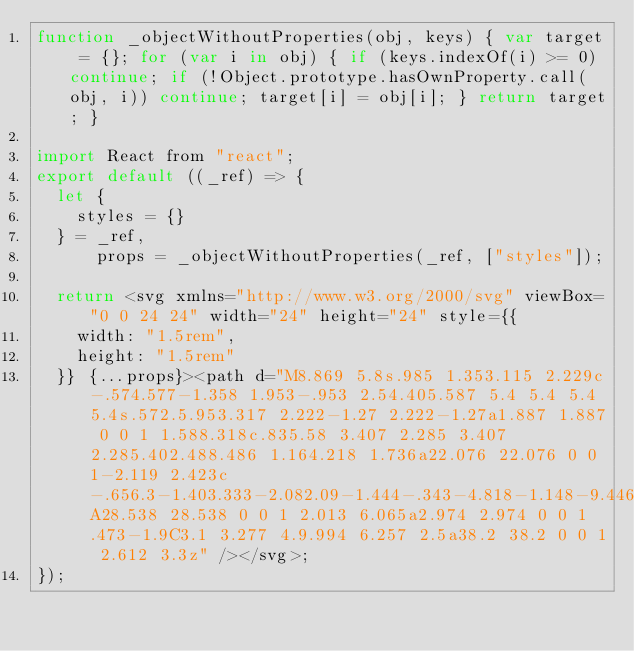<code> <loc_0><loc_0><loc_500><loc_500><_JavaScript_>function _objectWithoutProperties(obj, keys) { var target = {}; for (var i in obj) { if (keys.indexOf(i) >= 0) continue; if (!Object.prototype.hasOwnProperty.call(obj, i)) continue; target[i] = obj[i]; } return target; }

import React from "react";
export default ((_ref) => {
  let {
    styles = {}
  } = _ref,
      props = _objectWithoutProperties(_ref, ["styles"]);

  return <svg xmlns="http://www.w3.org/2000/svg" viewBox="0 0 24 24" width="24" height="24" style={{
    width: "1.5rem",
    height: "1.5rem"
  }} {...props}><path d="M8.869 5.8s.985 1.353.115 2.229c-.574.577-1.358 1.953-.953 2.54.405.587 5.4 5.4 5.4 5.4s.572.5.953.317 2.222-1.27 2.222-1.27a1.887 1.887 0 0 1 1.588.318c.835.58 3.407 2.285 3.407 2.285.402.488.486 1.164.218 1.736a22.076 22.076 0 0 1-2.119 2.423c-.656.3-1.403.333-2.082.09-1.444-.343-4.818-1.148-9.446-5.768A28.538 28.538 0 0 1 2.013 6.065a2.974 2.974 0 0 1 .473-1.9C3.1 3.277 4.9.994 6.257 2.5a38.2 38.2 0 0 1 2.612 3.3z" /></svg>;
});</code> 